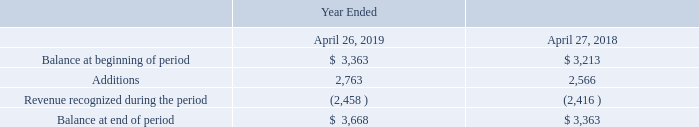The following tables summarize the activity related to deferred revenue and financed unearned services revenue (in millions):
During the years ended April 26, 2019 and April 27, 2018, we recognized $1,722 million and $1,806 million, respectively, that was included in the deferred revenue and financed unearned services revenue balance at the beginning of the respective periods.
As of April 26, 2019, the aggregate amount of the transaction price allocated to the remaining performance obligations related to customer contracts that are unsatisfied or partially unsatisfied was $3,668 million, which is equivalent to our deferred revenue and unearned services revenue balance. Because customer orders are typically placed on an as-needed basis, and cancellable without penalty prior to shipment, orders in backlog may not be a meaningful indicator of future revenue and have not been included in this amount. We expect to recognize as revenue approximately 50% of our deferred revenue and financed unearned services revenue balance in the next 12 months, approximately 25% in the next 13 to 24 months, and the remainder thereafter.
How much was included in the deferred revenue and financed unearned services revenue balance at the beginning of 2019?
Answer scale should be: million. 1,722. What were the additions in 2019?
Answer scale should be: million. 2,763. What was the balance at the end of period in 2018?
Answer scale should be: million. 3,363. What was the change in the balance at beginning of period between 2018 and 2019?
Answer scale should be: million. 3,363-3,213
Answer: 150. How many years did balance at end of period exceed $3,500 million? 2019
Answer: 1. What was the percentage change in additions between 2018 and 2019?
Answer scale should be: percent. (2,763-2,566)/2,566
Answer: 7.68. 